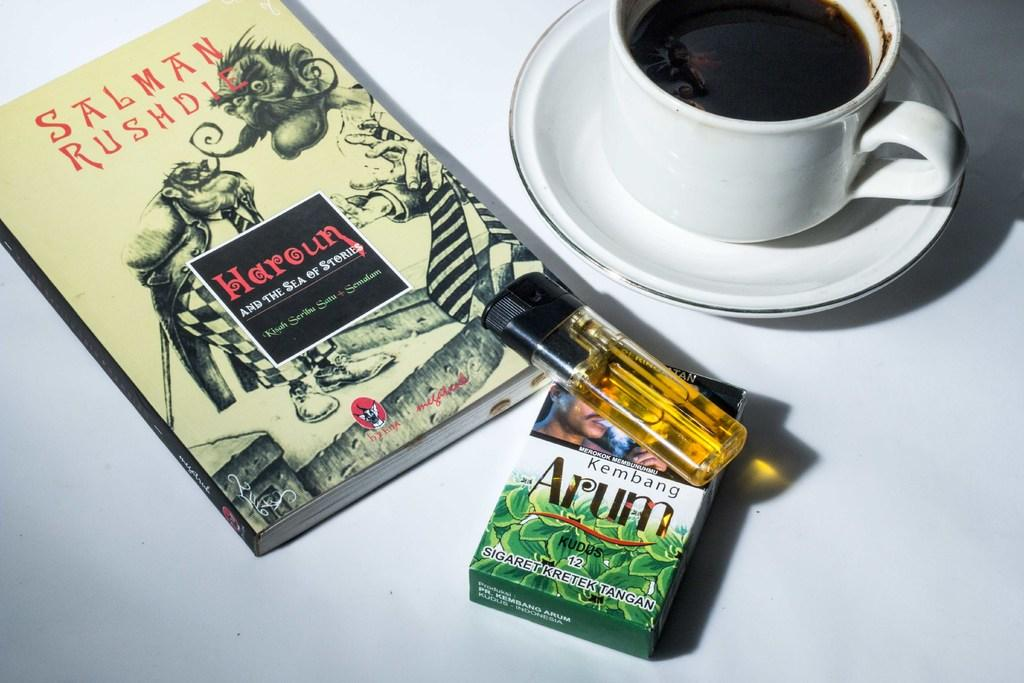<image>
Render a clear and concise summary of the photo. Pack of Arum with a lighter and a cup of coffee with a book 